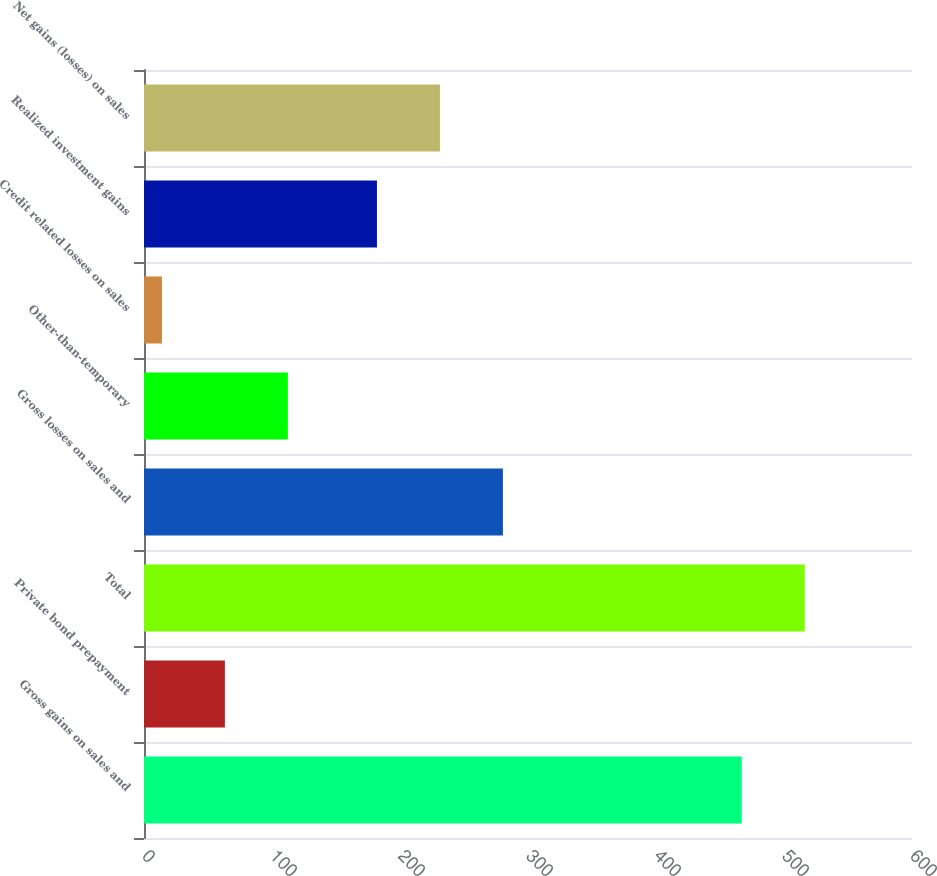Convert chart to OTSL. <chart><loc_0><loc_0><loc_500><loc_500><bar_chart><fcel>Gross gains on sales and<fcel>Private bond prepayment<fcel>Total<fcel>Gross losses on sales and<fcel>Other-than-temporary<fcel>Credit related losses on sales<fcel>Realized investment gains<fcel>Net gains (losses) on sales<nl><fcel>467<fcel>63.2<fcel>516.2<fcel>280.4<fcel>112.4<fcel>14<fcel>182<fcel>231.2<nl></chart> 